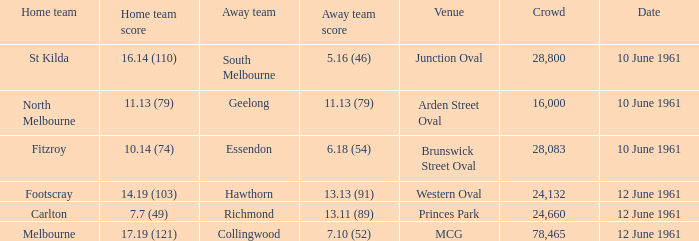Could you help me parse every detail presented in this table? {'header': ['Home team', 'Home team score', 'Away team', 'Away team score', 'Venue', 'Crowd', 'Date'], 'rows': [['St Kilda', '16.14 (110)', 'South Melbourne', '5.16 (46)', 'Junction Oval', '28,800', '10 June 1961'], ['North Melbourne', '11.13 (79)', 'Geelong', '11.13 (79)', 'Arden Street Oval', '16,000', '10 June 1961'], ['Fitzroy', '10.14 (74)', 'Essendon', '6.18 (54)', 'Brunswick Street Oval', '28,083', '10 June 1961'], ['Footscray', '14.19 (103)', 'Hawthorn', '13.13 (91)', 'Western Oval', '24,132', '12 June 1961'], ['Carlton', '7.7 (49)', 'Richmond', '13.11 (89)', 'Princes Park', '24,660', '12 June 1961'], ['Melbourne', '17.19 (121)', 'Collingwood', '7.10 (52)', 'MCG', '78,465', '12 June 1961']]} Which location has an audience exceeding 16,000 and a home team score of Princes Park. 